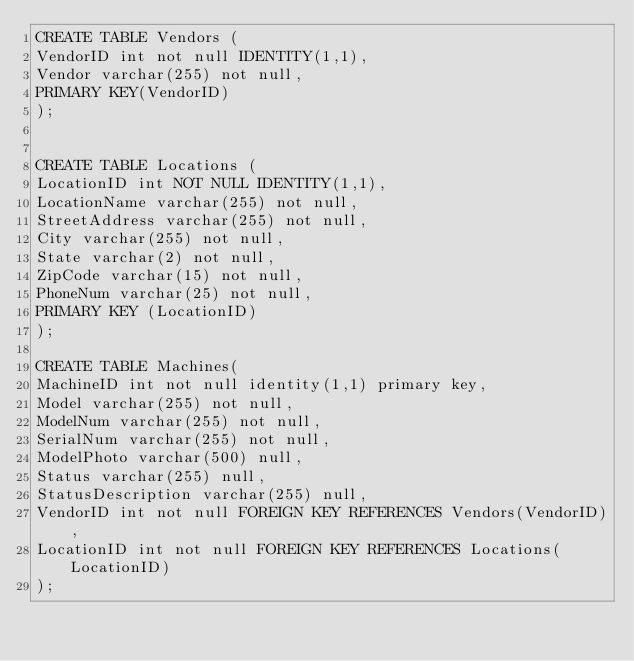Convert code to text. <code><loc_0><loc_0><loc_500><loc_500><_SQL_>CREATE TABLE Vendors (
VendorID int not null IDENTITY(1,1),
Vendor varchar(255) not null,
PRIMARY KEY(VendorID)
);


CREATE TABLE Locations (
LocationID int NOT NULL IDENTITY(1,1),
LocationName varchar(255) not null,
StreetAddress varchar(255) not null,
City varchar(255) not null,
State varchar(2) not null, 
ZipCode varchar(15) not null,
PhoneNum varchar(25) not null,
PRIMARY KEY (LocationID)
);

CREATE TABLE Machines(
MachineID int not null identity(1,1) primary key,
Model varchar(255) not null,
ModelNum varchar(255) not null,
SerialNum varchar(255) not null,
ModelPhoto varchar(500) null,
Status varchar(255) null,
StatusDescription varchar(255) null,
VendorID int not null FOREIGN KEY REFERENCES Vendors(VendorID),
LocationID int not null FOREIGN KEY REFERENCES Locations(LocationID)
);

</code> 